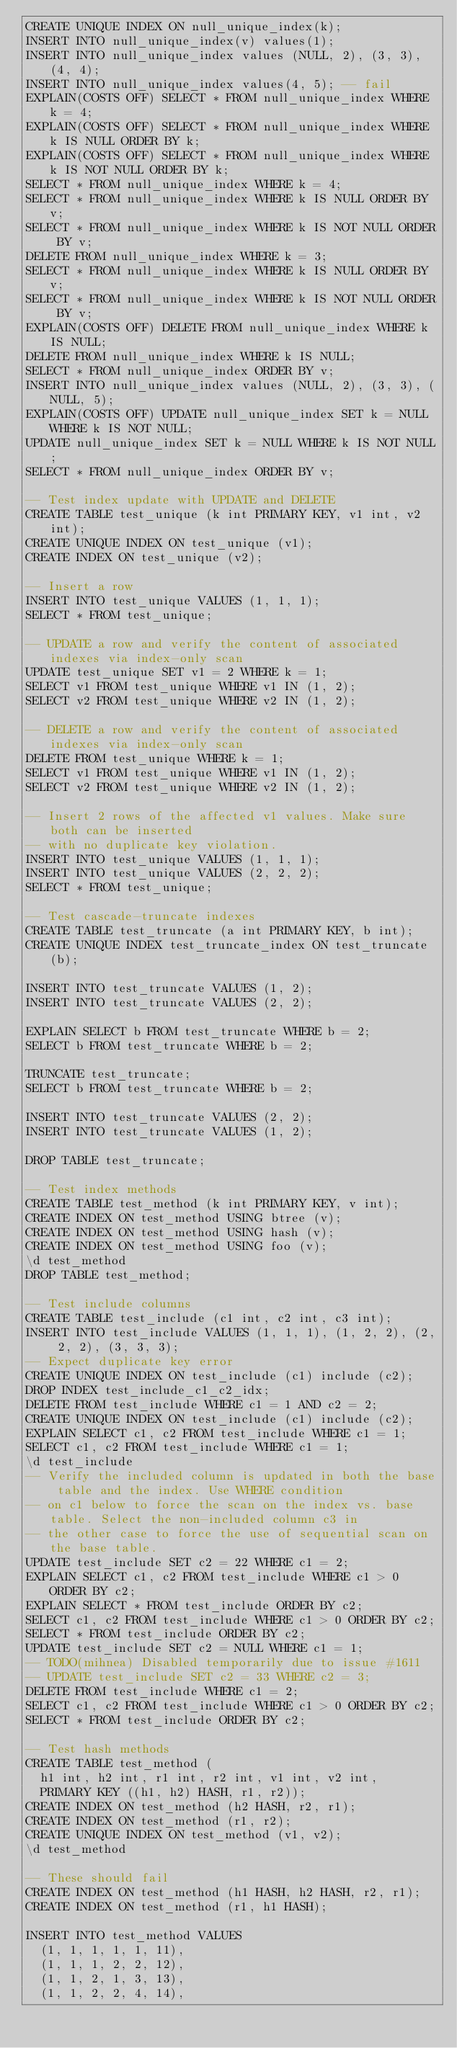Convert code to text. <code><loc_0><loc_0><loc_500><loc_500><_SQL_>CREATE UNIQUE INDEX ON null_unique_index(k);
INSERT INTO null_unique_index(v) values(1);
INSERT INTO null_unique_index values (NULL, 2), (3, 3), (4, 4);
INSERT INTO null_unique_index values(4, 5); -- fail
EXPLAIN(COSTS OFF) SELECT * FROM null_unique_index WHERE k = 4;
EXPLAIN(COSTS OFF) SELECT * FROM null_unique_index WHERE k IS NULL ORDER BY k;
EXPLAIN(COSTS OFF) SELECT * FROM null_unique_index WHERE k IS NOT NULL ORDER BY k;
SELECT * FROM null_unique_index WHERE k = 4;
SELECT * FROM null_unique_index WHERE k IS NULL ORDER BY v;
SELECT * FROM null_unique_index WHERE k IS NOT NULL ORDER BY v;
DELETE FROM null_unique_index WHERE k = 3;
SELECT * FROM null_unique_index WHERE k IS NULL ORDER BY v;
SELECT * FROM null_unique_index WHERE k IS NOT NULL ORDER BY v;
EXPLAIN(COSTS OFF) DELETE FROM null_unique_index WHERE k IS NULL;
DELETE FROM null_unique_index WHERE k IS NULL;
SELECT * FROM null_unique_index ORDER BY v;
INSERT INTO null_unique_index values (NULL, 2), (3, 3), (NULL, 5);
EXPLAIN(COSTS OFF) UPDATE null_unique_index SET k = NULL WHERE k IS NOT NULL;
UPDATE null_unique_index SET k = NULL WHERE k IS NOT NULL;
SELECT * FROM null_unique_index ORDER BY v;

-- Test index update with UPDATE and DELETE
CREATE TABLE test_unique (k int PRIMARY KEY, v1 int, v2 int);
CREATE UNIQUE INDEX ON test_unique (v1);
CREATE INDEX ON test_unique (v2);

-- Insert a row
INSERT INTO test_unique VALUES (1, 1, 1);
SELECT * FROM test_unique;

-- UPDATE a row and verify the content of associated indexes via index-only scan
UPDATE test_unique SET v1 = 2 WHERE k = 1;
SELECT v1 FROM test_unique WHERE v1 IN (1, 2);
SELECT v2 FROM test_unique WHERE v2 IN (1, 2);

-- DELETE a row and verify the content of associated indexes via index-only scan
DELETE FROM test_unique WHERE k = 1;
SELECT v1 FROM test_unique WHERE v1 IN (1, 2);
SELECT v2 FROM test_unique WHERE v2 IN (1, 2);

-- Insert 2 rows of the affected v1 values. Make sure both can be inserted
-- with no duplicate key violation.
INSERT INTO test_unique VALUES (1, 1, 1);
INSERT INTO test_unique VALUES (2, 2, 2);
SELECT * FROM test_unique;

-- Test cascade-truncate indexes
CREATE TABLE test_truncate (a int PRIMARY KEY, b int);
CREATE UNIQUE INDEX test_truncate_index ON test_truncate (b);

INSERT INTO test_truncate VALUES (1, 2);
INSERT INTO test_truncate VALUES (2, 2);

EXPLAIN SELECT b FROM test_truncate WHERE b = 2;
SELECT b FROM test_truncate WHERE b = 2;

TRUNCATE test_truncate;
SELECT b FROM test_truncate WHERE b = 2;

INSERT INTO test_truncate VALUES (2, 2);
INSERT INTO test_truncate VALUES (1, 2);

DROP TABLE test_truncate;

-- Test index methods
CREATE TABLE test_method (k int PRIMARY KEY, v int);
CREATE INDEX ON test_method USING btree (v);
CREATE INDEX ON test_method USING hash (v);
CREATE INDEX ON test_method USING foo (v);
\d test_method
DROP TABLE test_method;

-- Test include columns
CREATE TABLE test_include (c1 int, c2 int, c3 int);
INSERT INTO test_include VALUES (1, 1, 1), (1, 2, 2), (2, 2, 2), (3, 3, 3);
-- Expect duplicate key error
CREATE UNIQUE INDEX ON test_include (c1) include (c2);
DROP INDEX test_include_c1_c2_idx;
DELETE FROM test_include WHERE c1 = 1 AND c2 = 2;
CREATE UNIQUE INDEX ON test_include (c1) include (c2);
EXPLAIN SELECT c1, c2 FROM test_include WHERE c1 = 1;
SELECT c1, c2 FROM test_include WHERE c1 = 1;
\d test_include
-- Verify the included column is updated in both the base table and the index. Use WHERE condition
-- on c1 below to force the scan on the index vs. base table. Select the non-included column c3 in
-- the other case to force the use of sequential scan on the base table.
UPDATE test_include SET c2 = 22 WHERE c1 = 2;
EXPLAIN SELECT c1, c2 FROM test_include WHERE c1 > 0 ORDER BY c2;
EXPLAIN SELECT * FROM test_include ORDER BY c2;
SELECT c1, c2 FROM test_include WHERE c1 > 0 ORDER BY c2;
SELECT * FROM test_include ORDER BY c2;
UPDATE test_include SET c2 = NULL WHERE c1 = 1;
-- TODO(mihnea) Disabled temporarily due to issue #1611
-- UPDATE test_include SET c2 = 33 WHERE c2 = 3;
DELETE FROM test_include WHERE c1 = 2;
SELECT c1, c2 FROM test_include WHERE c1 > 0 ORDER BY c2;
SELECT * FROM test_include ORDER BY c2;

-- Test hash methods
CREATE TABLE test_method (
  h1 int, h2 int, r1 int, r2 int, v1 int, v2 int,
  PRIMARY KEY ((h1, h2) HASH, r1, r2));
CREATE INDEX ON test_method (h2 HASH, r2, r1);
CREATE INDEX ON test_method (r1, r2);
CREATE UNIQUE INDEX ON test_method (v1, v2);
\d test_method

-- These should fail
CREATE INDEX ON test_method (h1 HASH, h2 HASH, r2, r1);
CREATE INDEX ON test_method (r1, h1 HASH);

INSERT INTO test_method VALUES
  (1, 1, 1, 1, 1, 11),
  (1, 1, 1, 2, 2, 12),
  (1, 1, 2, 1, 3, 13),
  (1, 1, 2, 2, 4, 14),</code> 